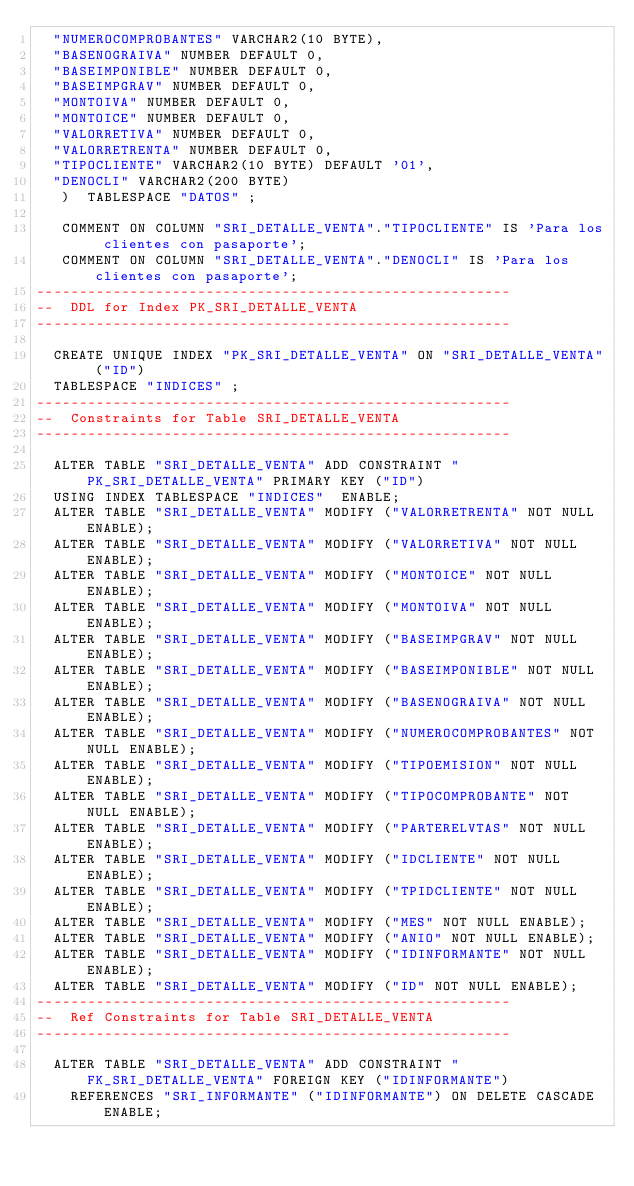<code> <loc_0><loc_0><loc_500><loc_500><_SQL_>	"NUMEROCOMPROBANTES" VARCHAR2(10 BYTE), 
	"BASENOGRAIVA" NUMBER DEFAULT 0, 
	"BASEIMPONIBLE" NUMBER DEFAULT 0, 
	"BASEIMPGRAV" NUMBER DEFAULT 0, 
	"MONTOIVA" NUMBER DEFAULT 0, 
	"MONTOICE" NUMBER DEFAULT 0, 
	"VALORRETIVA" NUMBER DEFAULT 0, 
	"VALORRETRENTA" NUMBER DEFAULT 0, 
	"TIPOCLIENTE" VARCHAR2(10 BYTE) DEFAULT '01', 
	"DENOCLI" VARCHAR2(200 BYTE)
   )  TABLESPACE "DATOS" ;

   COMMENT ON COLUMN "SRI_DETALLE_VENTA"."TIPOCLIENTE" IS 'Para los clientes con pasaporte';
   COMMENT ON COLUMN "SRI_DETALLE_VENTA"."DENOCLI" IS 'Para los clientes con pasaporte';
--------------------------------------------------------
--  DDL for Index PK_SRI_DETALLE_VENTA
--------------------------------------------------------

  CREATE UNIQUE INDEX "PK_SRI_DETALLE_VENTA" ON "SRI_DETALLE_VENTA" ("ID") 
  TABLESPACE "INDICES" ;
--------------------------------------------------------
--  Constraints for Table SRI_DETALLE_VENTA
--------------------------------------------------------

  ALTER TABLE "SRI_DETALLE_VENTA" ADD CONSTRAINT "PK_SRI_DETALLE_VENTA" PRIMARY KEY ("ID")
  USING INDEX TABLESPACE "INDICES"  ENABLE;
  ALTER TABLE "SRI_DETALLE_VENTA" MODIFY ("VALORRETRENTA" NOT NULL ENABLE);
  ALTER TABLE "SRI_DETALLE_VENTA" MODIFY ("VALORRETIVA" NOT NULL ENABLE);
  ALTER TABLE "SRI_DETALLE_VENTA" MODIFY ("MONTOICE" NOT NULL ENABLE);
  ALTER TABLE "SRI_DETALLE_VENTA" MODIFY ("MONTOIVA" NOT NULL ENABLE);
  ALTER TABLE "SRI_DETALLE_VENTA" MODIFY ("BASEIMPGRAV" NOT NULL ENABLE);
  ALTER TABLE "SRI_DETALLE_VENTA" MODIFY ("BASEIMPONIBLE" NOT NULL ENABLE);
  ALTER TABLE "SRI_DETALLE_VENTA" MODIFY ("BASENOGRAIVA" NOT NULL ENABLE);
  ALTER TABLE "SRI_DETALLE_VENTA" MODIFY ("NUMEROCOMPROBANTES" NOT NULL ENABLE);
  ALTER TABLE "SRI_DETALLE_VENTA" MODIFY ("TIPOEMISION" NOT NULL ENABLE);
  ALTER TABLE "SRI_DETALLE_VENTA" MODIFY ("TIPOCOMPROBANTE" NOT NULL ENABLE);
  ALTER TABLE "SRI_DETALLE_VENTA" MODIFY ("PARTERELVTAS" NOT NULL ENABLE);
  ALTER TABLE "SRI_DETALLE_VENTA" MODIFY ("IDCLIENTE" NOT NULL ENABLE);
  ALTER TABLE "SRI_DETALLE_VENTA" MODIFY ("TPIDCLIENTE" NOT NULL ENABLE);
  ALTER TABLE "SRI_DETALLE_VENTA" MODIFY ("MES" NOT NULL ENABLE);
  ALTER TABLE "SRI_DETALLE_VENTA" MODIFY ("ANIO" NOT NULL ENABLE);
  ALTER TABLE "SRI_DETALLE_VENTA" MODIFY ("IDINFORMANTE" NOT NULL ENABLE);
  ALTER TABLE "SRI_DETALLE_VENTA" MODIFY ("ID" NOT NULL ENABLE);
--------------------------------------------------------
--  Ref Constraints for Table SRI_DETALLE_VENTA
--------------------------------------------------------

  ALTER TABLE "SRI_DETALLE_VENTA" ADD CONSTRAINT "FK_SRI_DETALLE_VENTA" FOREIGN KEY ("IDINFORMANTE")
	  REFERENCES "SRI_INFORMANTE" ("IDINFORMANTE") ON DELETE CASCADE ENABLE;
</code> 